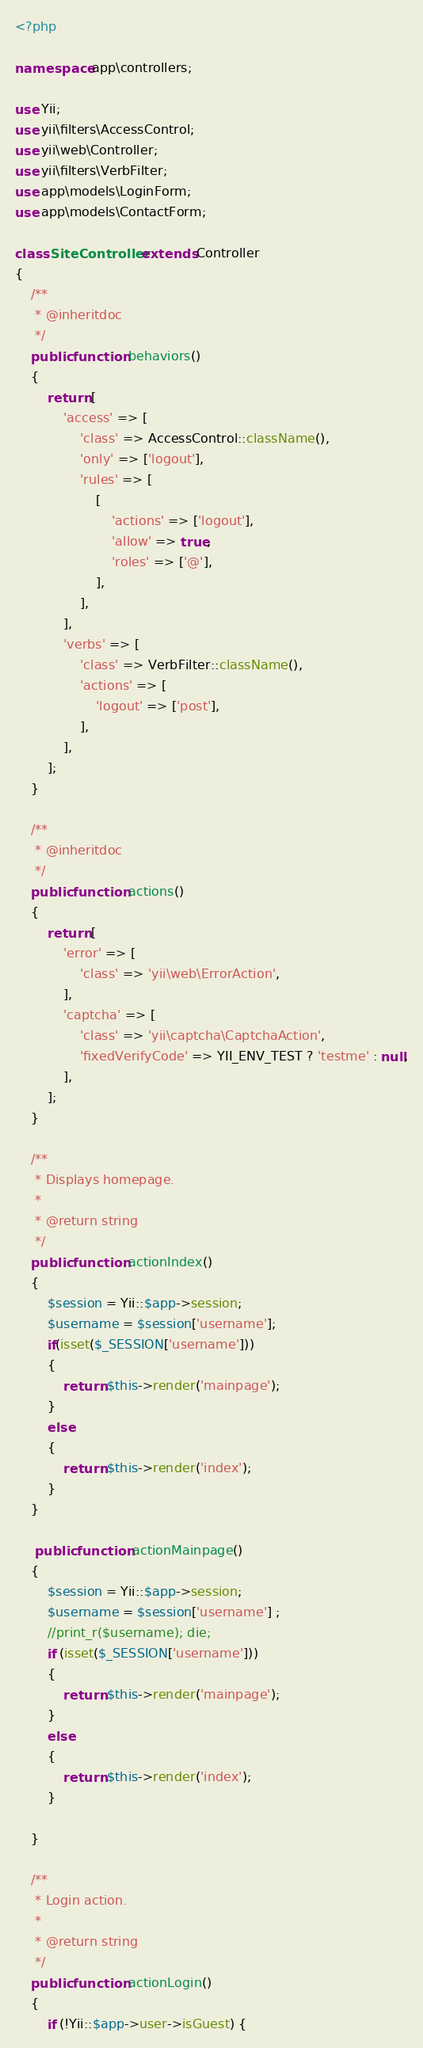Convert code to text. <code><loc_0><loc_0><loc_500><loc_500><_PHP_><?php

namespace app\controllers;

use Yii;
use yii\filters\AccessControl;
use yii\web\Controller;
use yii\filters\VerbFilter;
use app\models\LoginForm;
use app\models\ContactForm;

class SiteController extends Controller
{
    /**
     * @inheritdoc
     */
    public function behaviors()
    {
        return [
            'access' => [
                'class' => AccessControl::className(),
                'only' => ['logout'],
                'rules' => [
                    [
                        'actions' => ['logout'],
                        'allow' => true,
                        'roles' => ['@'],
                    ],
                ],
            ],
            'verbs' => [
                'class' => VerbFilter::className(),
                'actions' => [
                    'logout' => ['post'],
                ],
            ],
        ];
    }

    /**
     * @inheritdoc
     */
    public function actions()
    {
        return [
            'error' => [
                'class' => 'yii\web\ErrorAction',
            ],
            'captcha' => [
                'class' => 'yii\captcha\CaptchaAction',
                'fixedVerifyCode' => YII_ENV_TEST ? 'testme' : null,
            ],
        ];
    }

    /**
     * Displays homepage.
     *
     * @return string
     */
    public function actionIndex()
    {   
		$session = Yii::$app->session;
		$username = $session['username'];
		if(isset($_SESSION['username']))
		{
			return $this->render('mainpage');
		}
		else
		{
			return $this->render('index');
		}
    }
	
	 public function actionMainpage()
    {   
		$session = Yii::$app->session;
		$username = $session['username'] ;
		//print_r($username); die;
		if (isset($_SESSION['username']))
		{ 
			return $this->render('mainpage');
		}
		else
		{
			return $this->render('index');
		}
		
    }

    /**
     * Login action.
     *
     * @return string
     */
    public function actionLogin()
    {
        if (!Yii::$app->user->isGuest) {</code> 